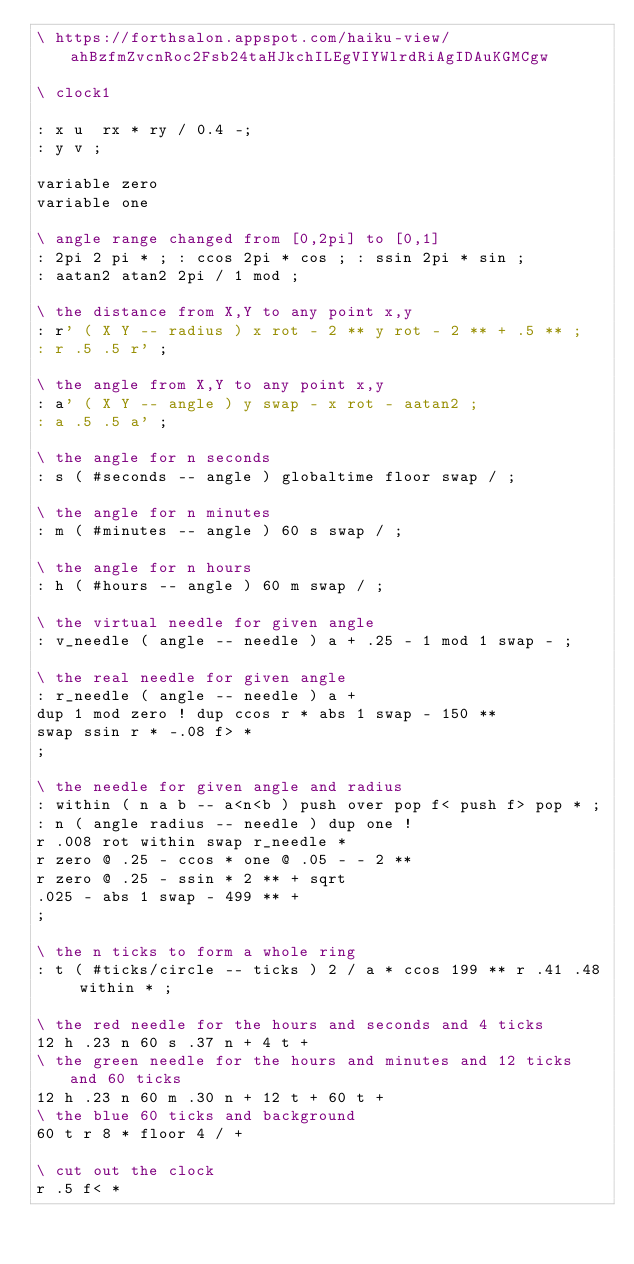<code> <loc_0><loc_0><loc_500><loc_500><_Forth_>\ https://forthsalon.appspot.com/haiku-view/ahBzfmZvcnRoc2Fsb24taHJkchILEgVIYWlrdRiAgIDAuKGMCgw

\ clock1

: x u  rx * ry / 0.4 -;
: y v ;

variable zero
variable one

\ angle range changed from [0,2pi] to [0,1]
: 2pi 2 pi * ; : ccos 2pi * cos ; : ssin 2pi * sin ;
: aatan2 atan2 2pi / 1 mod ;

\ the distance from X,Y to any point x,y
: r' ( X Y -- radius ) x rot - 2 ** y rot - 2 ** + .5 ** ;
: r .5 .5 r' ;

\ the angle from X,Y to any point x,y
: a' ( X Y -- angle ) y swap - x rot - aatan2 ;
: a .5 .5 a' ;

\ the angle for n seconds
: s ( #seconds -- angle ) globaltime floor swap / ;

\ the angle for n minutes
: m ( #minutes -- angle ) 60 s swap / ;

\ the angle for n hours
: h ( #hours -- angle ) 60 m swap / ;

\ the virtual needle for given angle
: v_needle ( angle -- needle ) a + .25 - 1 mod 1 swap - ;

\ the real needle for given angle
: r_needle ( angle -- needle ) a +
dup 1 mod zero ! dup ccos r * abs 1 swap - 150 **
swap ssin r * -.08 f> *
;

\ the needle for given angle and radius
: within ( n a b -- a<n<b ) push over pop f< push f> pop * ;
: n ( angle radius -- needle ) dup one !
r .008 rot within swap r_needle *
r zero @ .25 - ccos * one @ .05 - - 2 **
r zero @ .25 - ssin * 2 ** + sqrt
.025 - abs 1 swap - 499 ** +
;

\ the n ticks to form a whole ring
: t ( #ticks/circle -- ticks ) 2 / a * ccos 199 ** r .41 .48 within * ;

\ the red needle for the hours and seconds and 4 ticks
12 h .23 n 60 s .37 n + 4 t +
\ the green needle for the hours and minutes and 12 ticks and 60 ticks
12 h .23 n 60 m .30 n + 12 t + 60 t +
\ the blue 60 ticks and background
60 t r 8 * floor 4 / +

\ cut out the clock
r .5 f< *</code> 